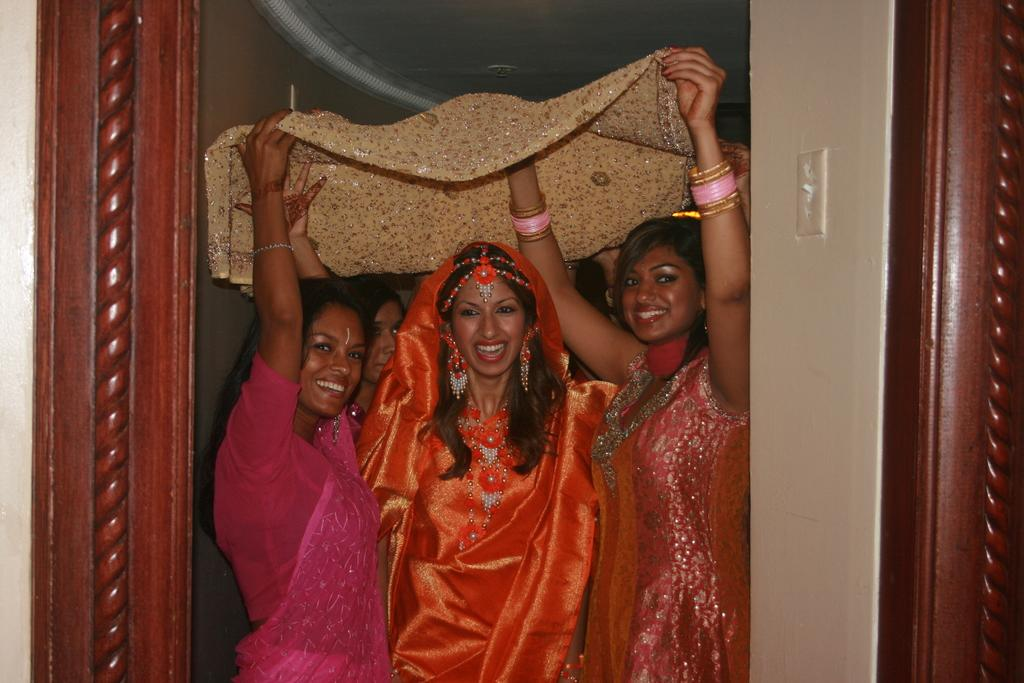Who are the people in the image? There are women and a bridegroom in the image. What are the women doing in the image? The women are standing and holding a cloth. What is the bridegroom wearing in the image? The bridegroom is wearing an orange dress. Where are the women and bridegroom located in the image? They are standing between an entrance door. What did the women learn from the history of the rake in the image? There is no rake or mention of learning history in the image. 